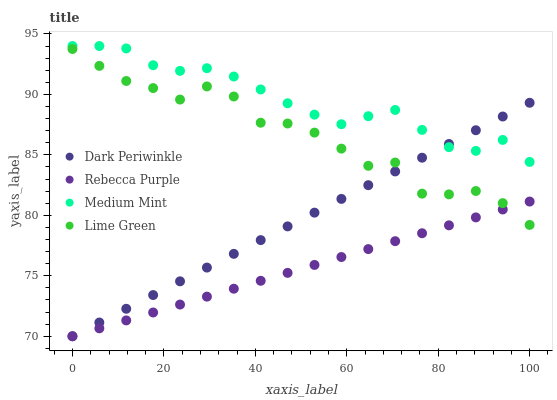Does Rebecca Purple have the minimum area under the curve?
Answer yes or no. Yes. Does Medium Mint have the maximum area under the curve?
Answer yes or no. Yes. Does Lime Green have the minimum area under the curve?
Answer yes or no. No. Does Lime Green have the maximum area under the curve?
Answer yes or no. No. Is Dark Periwinkle the smoothest?
Answer yes or no. Yes. Is Lime Green the roughest?
Answer yes or no. Yes. Is Lime Green the smoothest?
Answer yes or no. No. Is Dark Periwinkle the roughest?
Answer yes or no. No. Does Dark Periwinkle have the lowest value?
Answer yes or no. Yes. Does Lime Green have the lowest value?
Answer yes or no. No. Does Medium Mint have the highest value?
Answer yes or no. Yes. Does Lime Green have the highest value?
Answer yes or no. No. Is Lime Green less than Medium Mint?
Answer yes or no. Yes. Is Medium Mint greater than Rebecca Purple?
Answer yes or no. Yes. Does Dark Periwinkle intersect Rebecca Purple?
Answer yes or no. Yes. Is Dark Periwinkle less than Rebecca Purple?
Answer yes or no. No. Is Dark Periwinkle greater than Rebecca Purple?
Answer yes or no. No. Does Lime Green intersect Medium Mint?
Answer yes or no. No. 